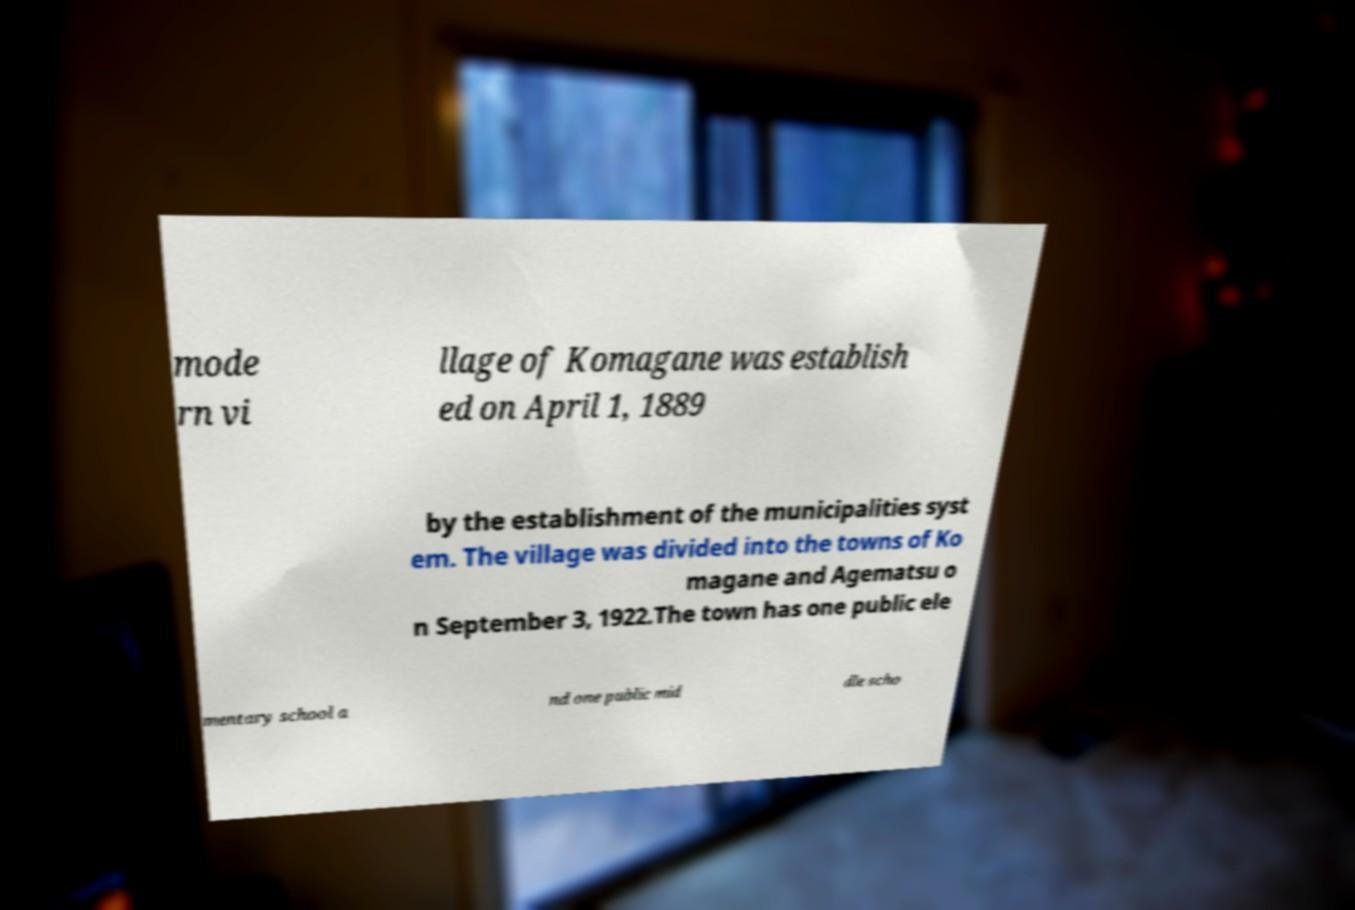For documentation purposes, I need the text within this image transcribed. Could you provide that? mode rn vi llage of Komagane was establish ed on April 1, 1889 by the establishment of the municipalities syst em. The village was divided into the towns of Ko magane and Agematsu o n September 3, 1922.The town has one public ele mentary school a nd one public mid dle scho 